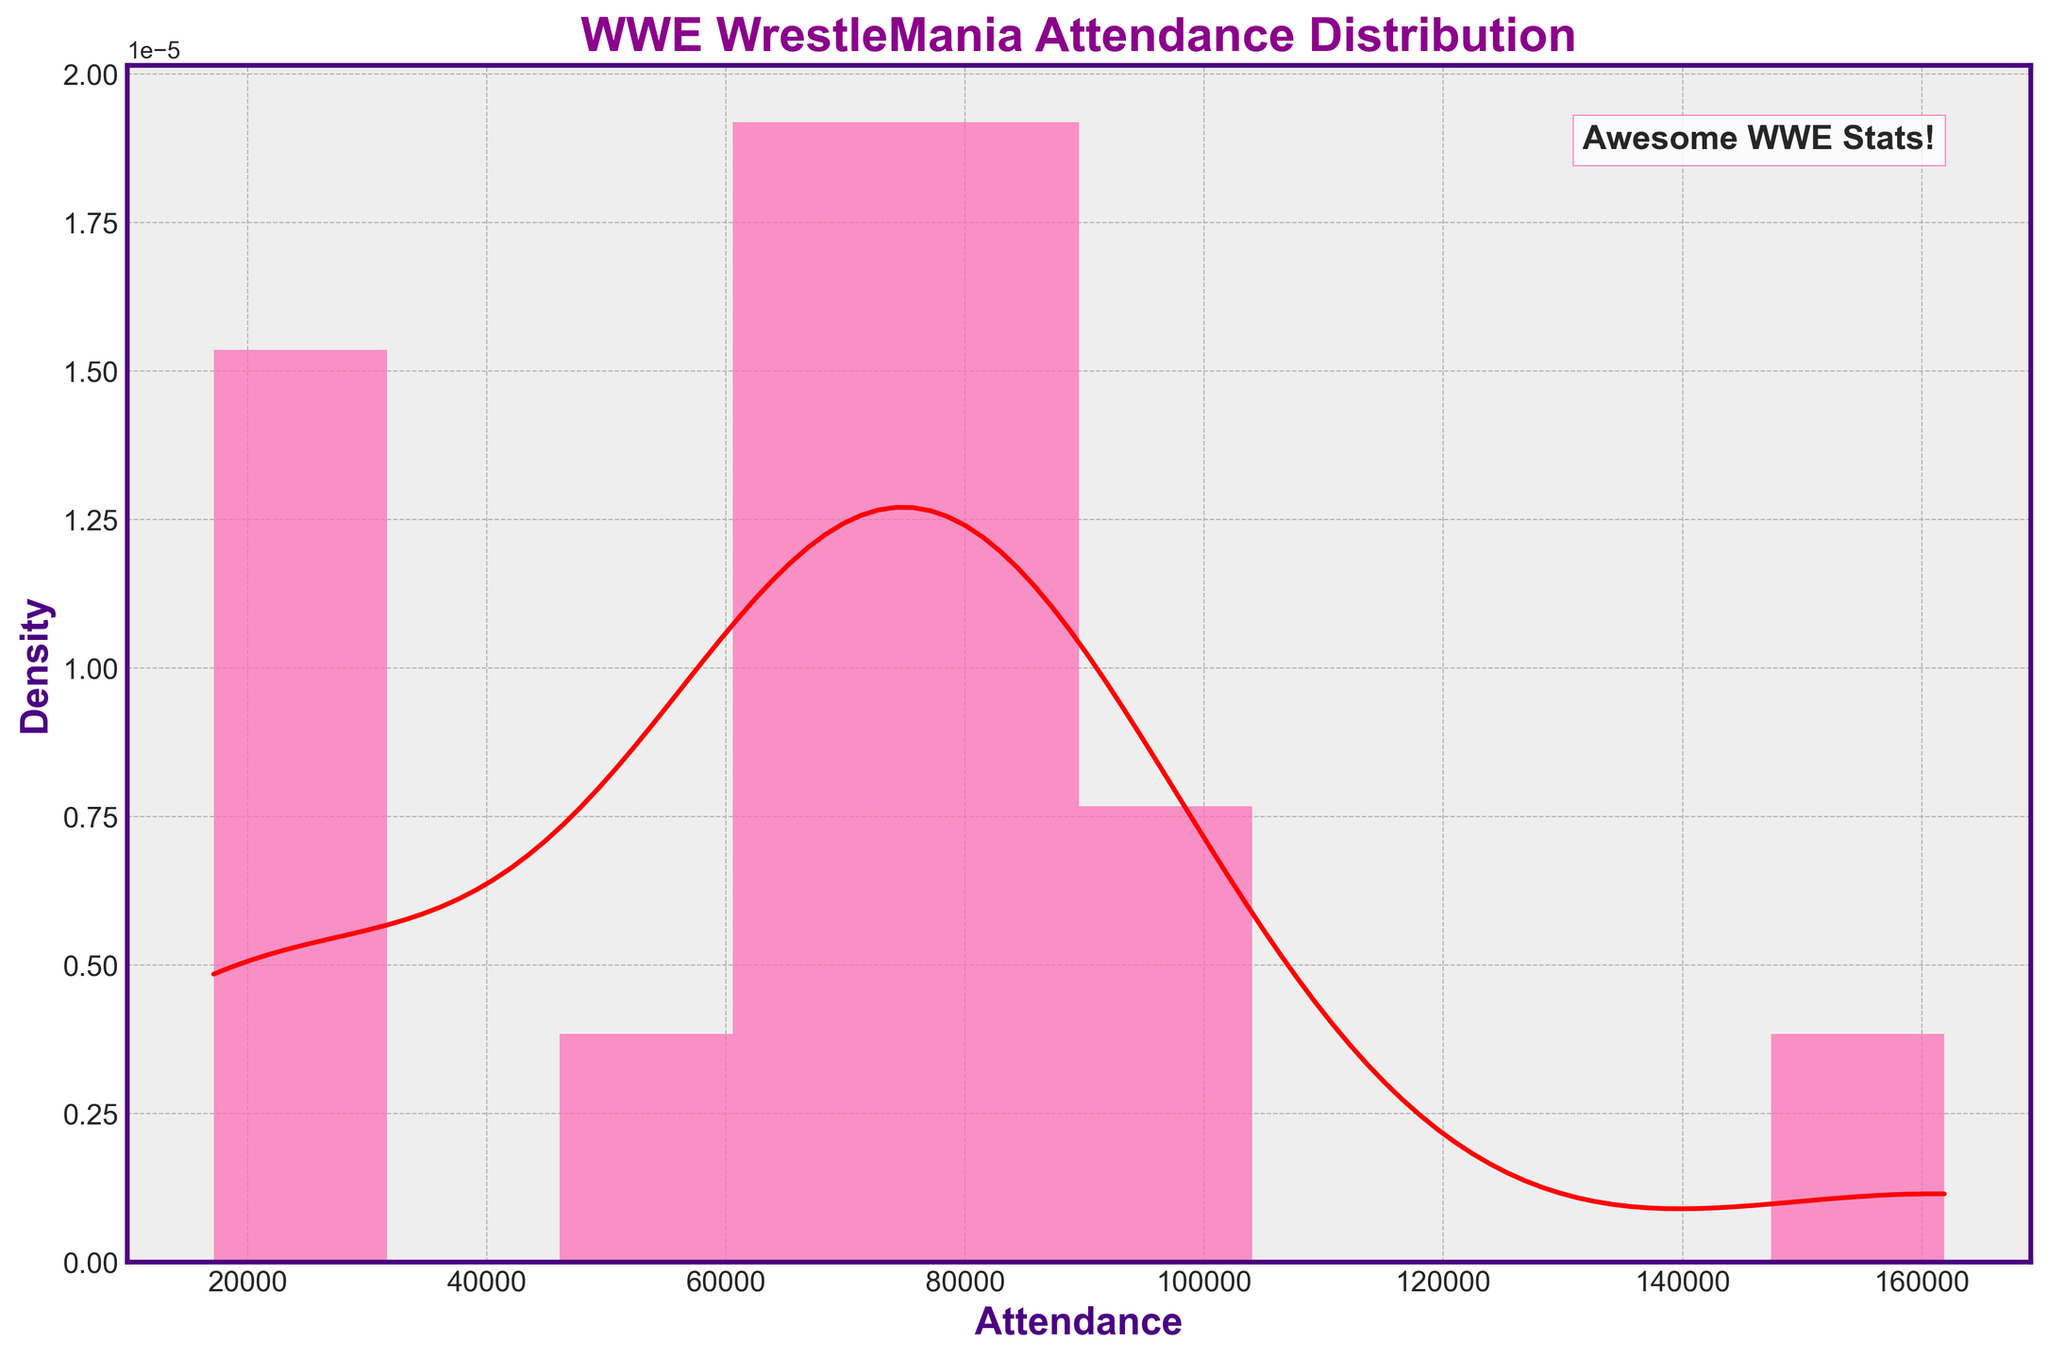What is the title of the histogram? The title of the histogram is displayed prominently at the top of the plot.
Answer: WWE WrestleMania Attendance Distribution What are the labels of the X and Y axes? The labels for the axes are provided right next to them on the plot.
Answer: Attendance (X-axis); Density (Y-axis) How many attendance bins are there in the histogram? By counting the bars in the histogram, you can determine the number of bins.
Answer: 10 What is the color of the attendance histogram bars? To determine the color of the bars, observe their appearance in the plot.
Answer: Pink Which year had the highest attendance, according to the histogram? The histogram doesn’t show specific years; however, the KDE curve peak can give a clue if interpreted with exact knowledge of the data. The highest attendance figure in the data provided is 161892 for the year 2023, which aligns with the highest peak.
Answer: 2023 Between what range of attendance figures does the KDE curve peak? The KDE curve peaks at the highest density point indicating the most common attendance figure. By examining the KDE peak position horizontally, you can determine this range.
Answer: Around 70,000 to 80,000 What is the approximate median attendance based on the histogram and KDE? The median is the middle value, which can be inferred where the KDE curve balances on both sides. By observing the center of the KDE distribution, the median falls near the center peak. With the list data median value 74635, it aligns around this zone.
Answer: Approximately 74,635 How many times did the attendance exceed 90,000? We use the data directly since the histogram shows densities, not exact counts. Checking the years 1987, 2016, and 2023 gives this count.
Answer: 3 times What is the least attended WrestleMania event? The histogram doesn't show specific years, but the lowest bin on the attendance range implies the least attendance. By referring to the data, the lowest attendance is 17155 in 2006.
Answer: 2006 Describe how the KDE curve helps in understanding the distribution of attendance figures? The KDE curve smooths the histogram bins into a continuous probability density function, which helps in visualizing the overall trend and distribution of attendance figures more fluidly.
Answer: It shows trends and common attendance ranges more clearly than the histogram alone 